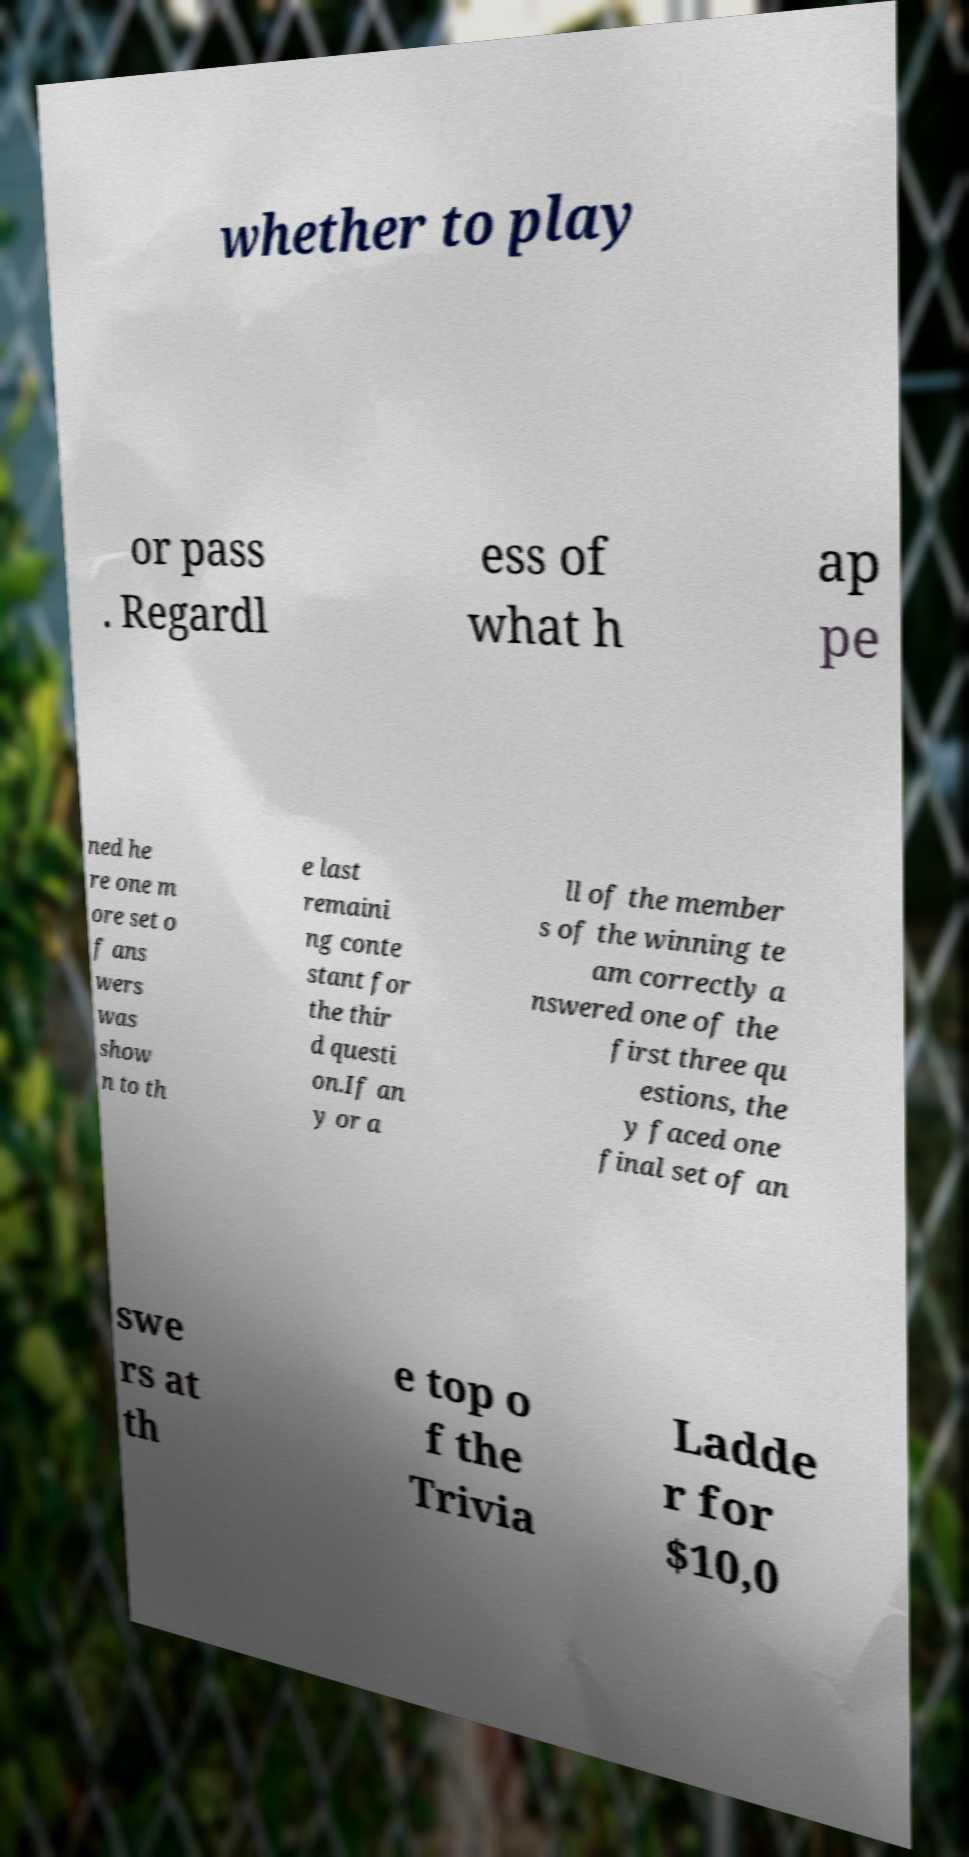There's text embedded in this image that I need extracted. Can you transcribe it verbatim? whether to play or pass . Regardl ess of what h ap pe ned he re one m ore set o f ans wers was show n to th e last remaini ng conte stant for the thir d questi on.If an y or a ll of the member s of the winning te am correctly a nswered one of the first three qu estions, the y faced one final set of an swe rs at th e top o f the Trivia Ladde r for $10,0 